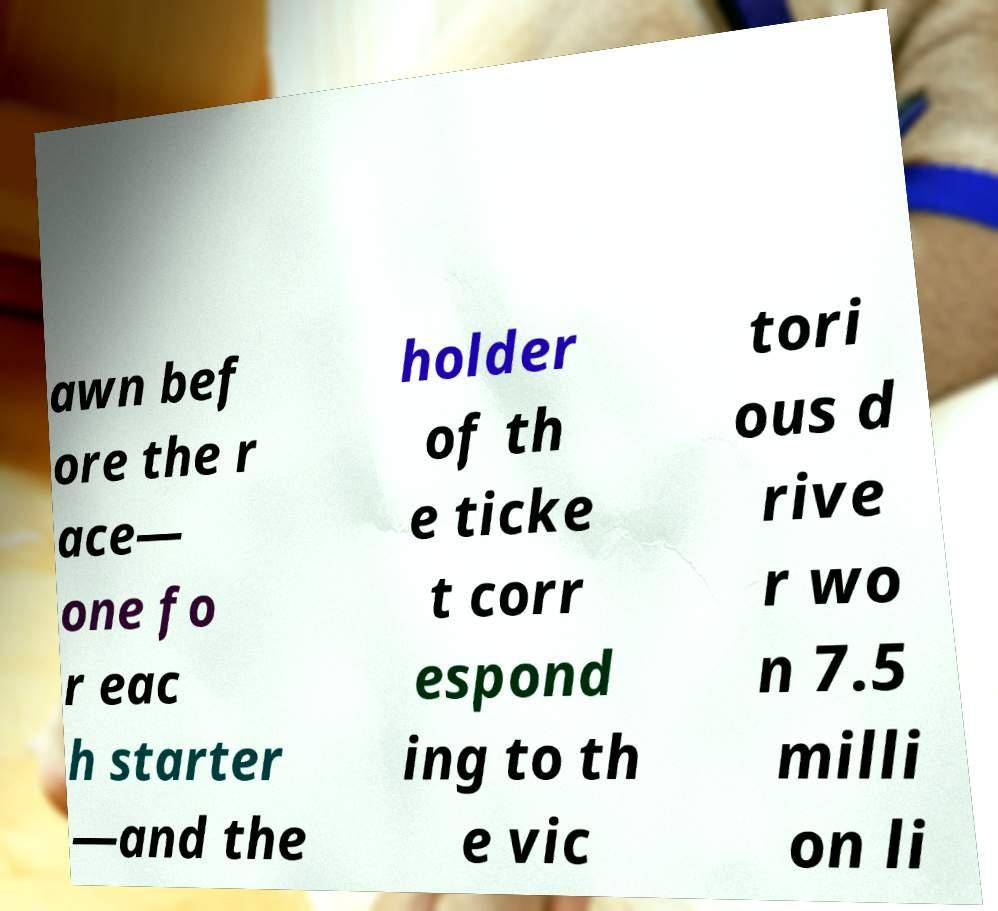Please read and relay the text visible in this image. What does it say? awn bef ore the r ace— one fo r eac h starter —and the holder of th e ticke t corr espond ing to th e vic tori ous d rive r wo n 7.5 milli on li 